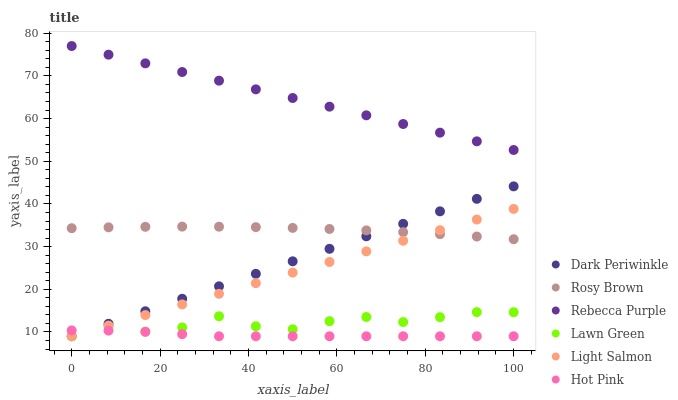Does Hot Pink have the minimum area under the curve?
Answer yes or no. Yes. Does Rebecca Purple have the maximum area under the curve?
Answer yes or no. Yes. Does Light Salmon have the minimum area under the curve?
Answer yes or no. No. Does Light Salmon have the maximum area under the curve?
Answer yes or no. No. Is Dark Periwinkle the smoothest?
Answer yes or no. Yes. Is Lawn Green the roughest?
Answer yes or no. Yes. Is Light Salmon the smoothest?
Answer yes or no. No. Is Light Salmon the roughest?
Answer yes or no. No. Does Lawn Green have the lowest value?
Answer yes or no. Yes. Does Rosy Brown have the lowest value?
Answer yes or no. No. Does Rebecca Purple have the highest value?
Answer yes or no. Yes. Does Light Salmon have the highest value?
Answer yes or no. No. Is Hot Pink less than Rebecca Purple?
Answer yes or no. Yes. Is Rebecca Purple greater than Rosy Brown?
Answer yes or no. Yes. Does Hot Pink intersect Lawn Green?
Answer yes or no. Yes. Is Hot Pink less than Lawn Green?
Answer yes or no. No. Is Hot Pink greater than Lawn Green?
Answer yes or no. No. Does Hot Pink intersect Rebecca Purple?
Answer yes or no. No. 